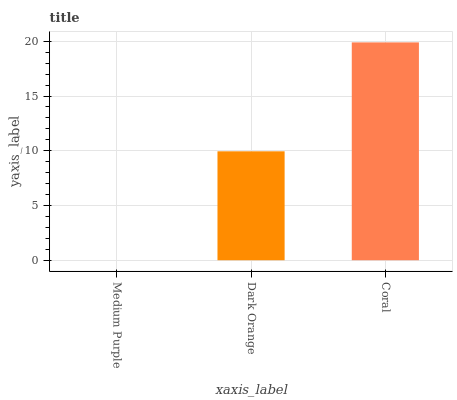Is Medium Purple the minimum?
Answer yes or no. Yes. Is Coral the maximum?
Answer yes or no. Yes. Is Dark Orange the minimum?
Answer yes or no. No. Is Dark Orange the maximum?
Answer yes or no. No. Is Dark Orange greater than Medium Purple?
Answer yes or no. Yes. Is Medium Purple less than Dark Orange?
Answer yes or no. Yes. Is Medium Purple greater than Dark Orange?
Answer yes or no. No. Is Dark Orange less than Medium Purple?
Answer yes or no. No. Is Dark Orange the high median?
Answer yes or no. Yes. Is Dark Orange the low median?
Answer yes or no. Yes. Is Medium Purple the high median?
Answer yes or no. No. Is Coral the low median?
Answer yes or no. No. 